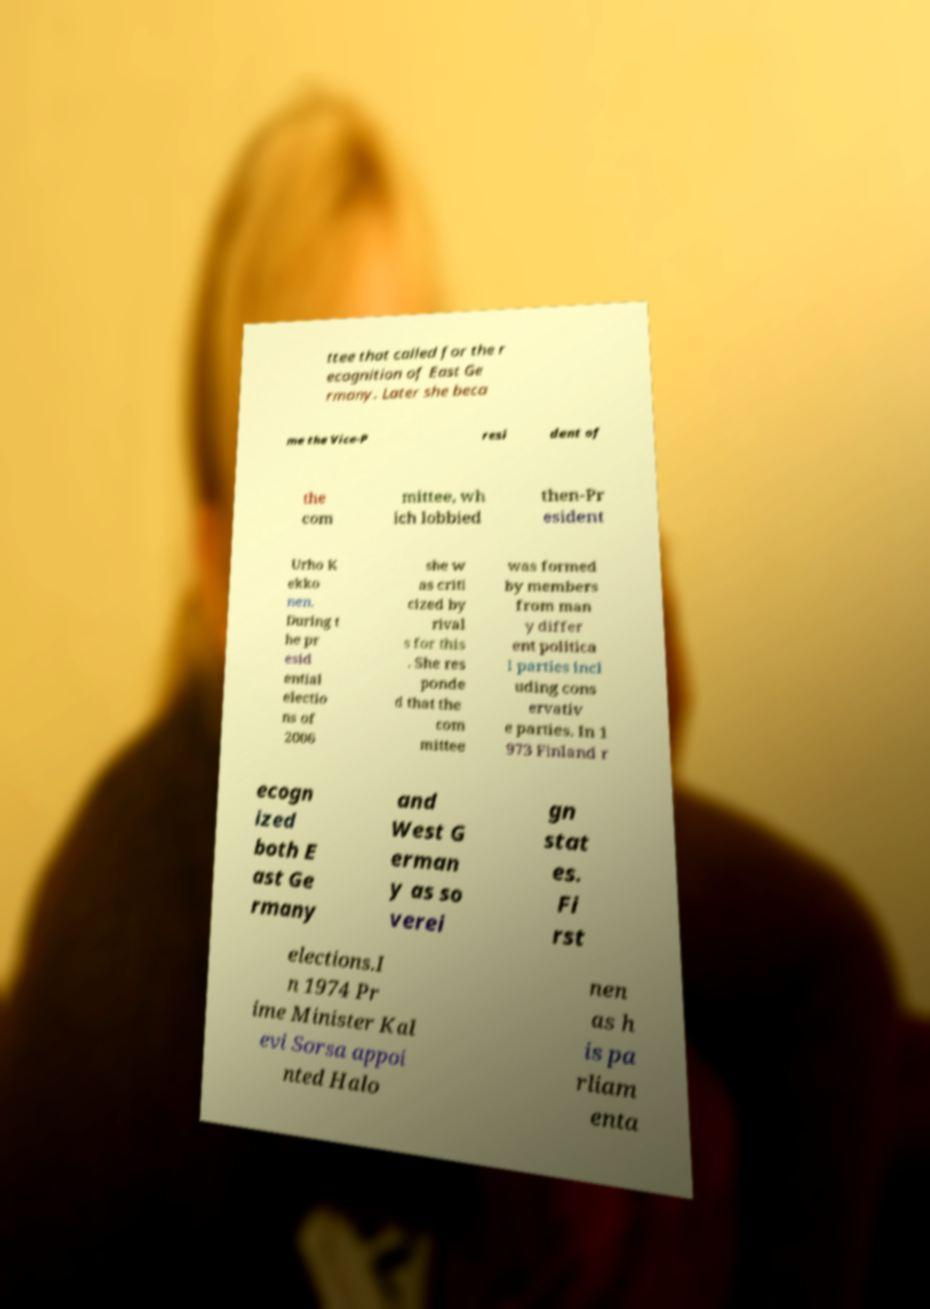There's text embedded in this image that I need extracted. Can you transcribe it verbatim? ttee that called for the r ecognition of East Ge rmany. Later she beca me the Vice-P resi dent of the com mittee, wh ich lobbied then-Pr esident Urho K ekko nen. During t he pr esid ential electio ns of 2006 she w as criti cized by rival s for this . She res ponde d that the com mittee was formed by members from man y differ ent politica l parties incl uding cons ervativ e parties. In 1 973 Finland r ecogn ized both E ast Ge rmany and West G erman y as so verei gn stat es. Fi rst elections.I n 1974 Pr ime Minister Kal evi Sorsa appoi nted Halo nen as h is pa rliam enta 